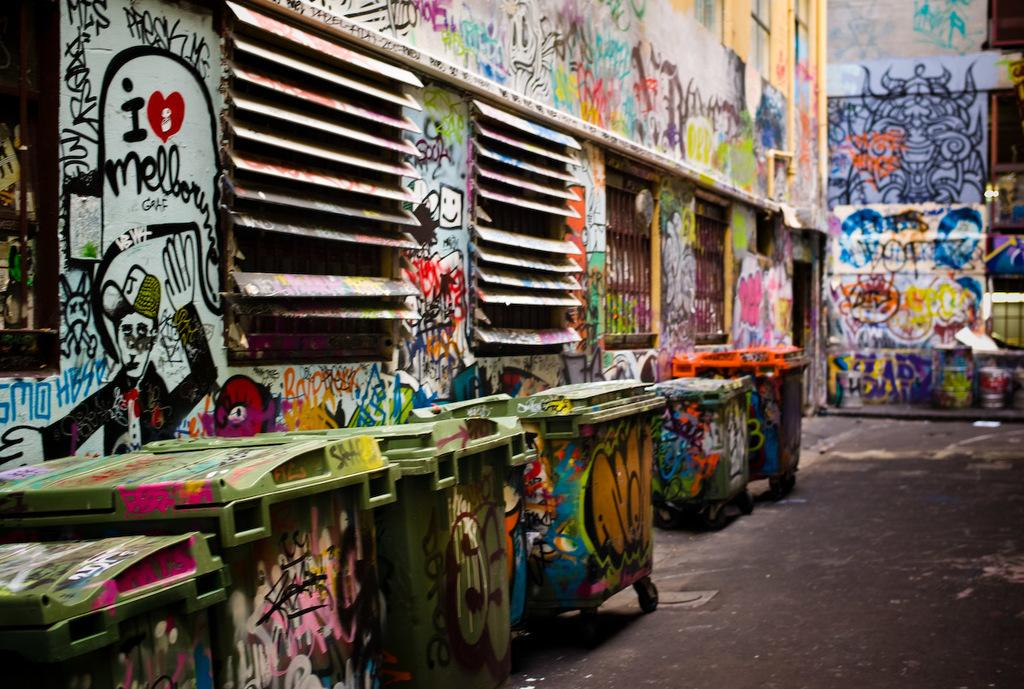<image>
Render a clear and concise summary of the photo. Trash cans and walls with graffiti on them in an alley. 